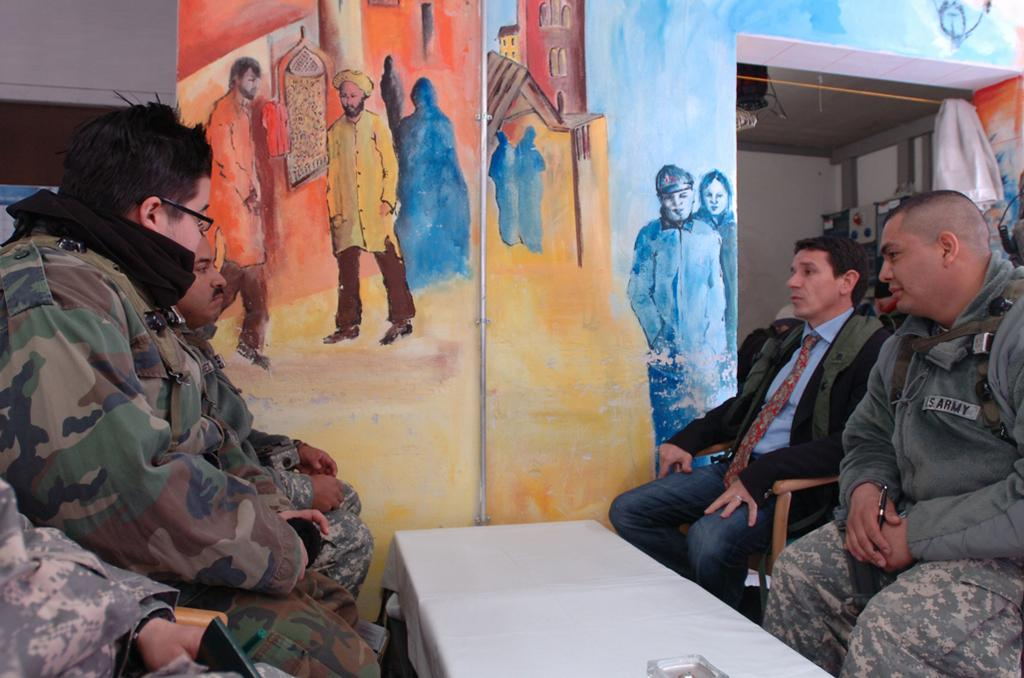How many people are in the image? There is a group of people in the image. What are the people doing in the image? The people are seated on chairs. What is in front of the people? There is a table in front of the people. What can be seen on the wall in the image? There is a wall painting visible in the image. Can you see a window in the image? There is no window visible in the image. What type of love is being expressed in the image? There is no indication of love or any emotion being expressed in the image. 